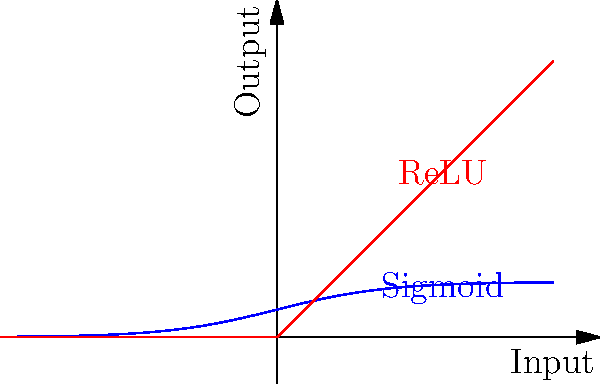In the context of machine learning for physics simulations in 3D animations, which activation function would be more suitable for modeling non-linear physical behaviors, such as fluid dynamics or cloth simulations: Sigmoid or ReLU (Rectified Linear Unit)? To answer this question, let's consider the properties of both activation functions and their implications for physics simulations:

1. Sigmoid function:
   - Formula: $f(x) = \frac{1}{1 + e^{-x}}$
   - Output range: (0, 1)
   - Smooth, continuous function
   - Gradient becomes very small for large positive or negative inputs (vanishing gradient problem)

2. ReLU (Rectified Linear Unit):
   - Formula: $f(x) = \max(0, x)$
   - Output range: [0, ∞)
   - Non-smooth at x = 0, but computationally efficient
   - No vanishing gradient problem for positive inputs

For physics simulations in 3D animations:

1. Non-linearity: Physical phenomena often exhibit non-linear behaviors. Both Sigmoid and ReLU can model non-linearity, but Sigmoid might be better for smooth, continuous transitions.

2. Range: Physics simulations often require a wide range of output values. ReLU's unbounded positive range is more suitable for representing various physical quantities.

3. Computational efficiency: ReLU is computationally more efficient, which is crucial for real-time simulations in 3D animations.

4. Gradient flow: ReLU's non-vanishing gradient for positive inputs allows for better gradient flow during backpropagation, leading to faster learning of complex physical behaviors.

5. Sparsity: ReLU promotes sparsity in the network, which can be beneficial for learning sparse physical interactions.

Considering these factors, ReLU is generally more suitable for modeling non-linear physical behaviors in 3D animations. Its unbounded positive range, computational efficiency, and better gradient flow make it more appropriate for complex physics simulations like fluid dynamics or cloth simulations.
Answer: ReLU (Rectified Linear Unit) 